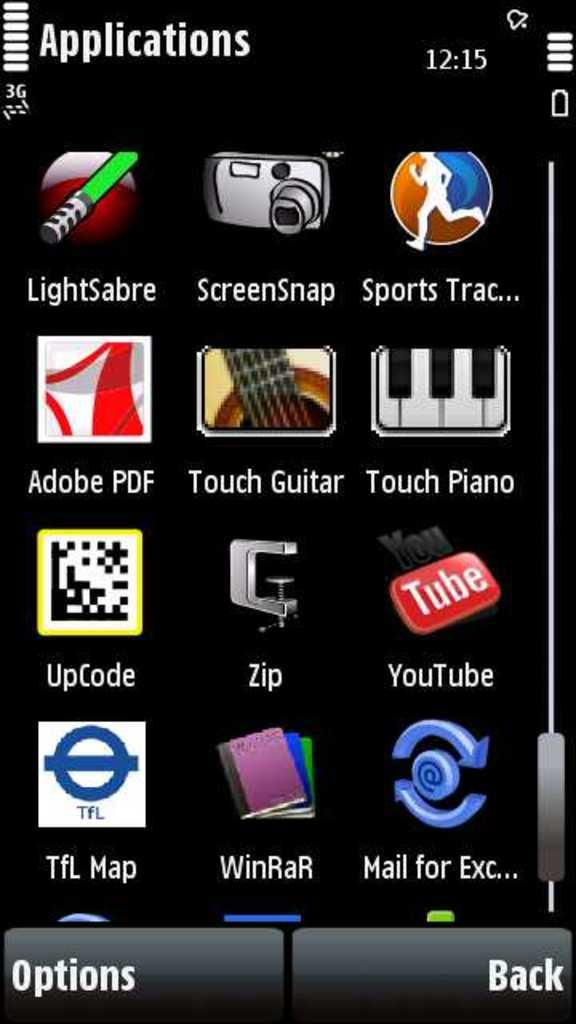<image>
Create a compact narrative representing the image presented. looks like the menu on a app section of phone with many different apps 